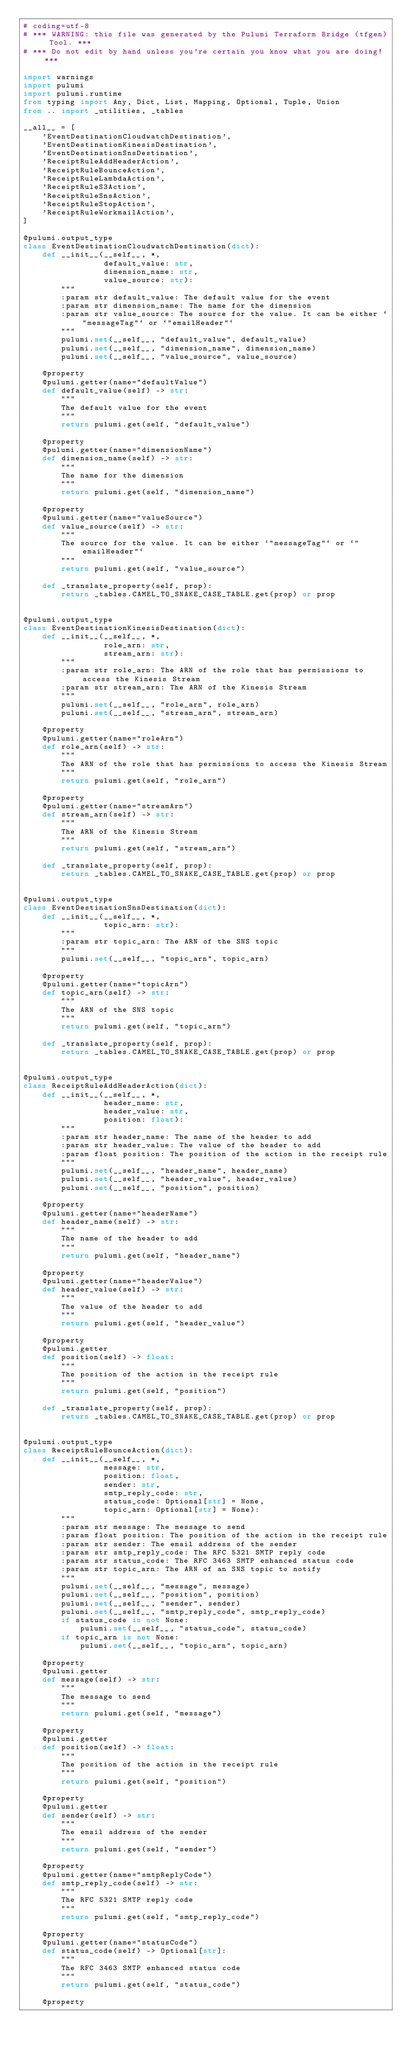<code> <loc_0><loc_0><loc_500><loc_500><_Python_># coding=utf-8
# *** WARNING: this file was generated by the Pulumi Terraform Bridge (tfgen) Tool. ***
# *** Do not edit by hand unless you're certain you know what you are doing! ***

import warnings
import pulumi
import pulumi.runtime
from typing import Any, Dict, List, Mapping, Optional, Tuple, Union
from .. import _utilities, _tables

__all__ = [
    'EventDestinationCloudwatchDestination',
    'EventDestinationKinesisDestination',
    'EventDestinationSnsDestination',
    'ReceiptRuleAddHeaderAction',
    'ReceiptRuleBounceAction',
    'ReceiptRuleLambdaAction',
    'ReceiptRuleS3Action',
    'ReceiptRuleSnsAction',
    'ReceiptRuleStopAction',
    'ReceiptRuleWorkmailAction',
]

@pulumi.output_type
class EventDestinationCloudwatchDestination(dict):
    def __init__(__self__, *,
                 default_value: str,
                 dimension_name: str,
                 value_source: str):
        """
        :param str default_value: The default value for the event
        :param str dimension_name: The name for the dimension
        :param str value_source: The source for the value. It can be either `"messageTag"` or `"emailHeader"`
        """
        pulumi.set(__self__, "default_value", default_value)
        pulumi.set(__self__, "dimension_name", dimension_name)
        pulumi.set(__self__, "value_source", value_source)

    @property
    @pulumi.getter(name="defaultValue")
    def default_value(self) -> str:
        """
        The default value for the event
        """
        return pulumi.get(self, "default_value")

    @property
    @pulumi.getter(name="dimensionName")
    def dimension_name(self) -> str:
        """
        The name for the dimension
        """
        return pulumi.get(self, "dimension_name")

    @property
    @pulumi.getter(name="valueSource")
    def value_source(self) -> str:
        """
        The source for the value. It can be either `"messageTag"` or `"emailHeader"`
        """
        return pulumi.get(self, "value_source")

    def _translate_property(self, prop):
        return _tables.CAMEL_TO_SNAKE_CASE_TABLE.get(prop) or prop


@pulumi.output_type
class EventDestinationKinesisDestination(dict):
    def __init__(__self__, *,
                 role_arn: str,
                 stream_arn: str):
        """
        :param str role_arn: The ARN of the role that has permissions to access the Kinesis Stream
        :param str stream_arn: The ARN of the Kinesis Stream
        """
        pulumi.set(__self__, "role_arn", role_arn)
        pulumi.set(__self__, "stream_arn", stream_arn)

    @property
    @pulumi.getter(name="roleArn")
    def role_arn(self) -> str:
        """
        The ARN of the role that has permissions to access the Kinesis Stream
        """
        return pulumi.get(self, "role_arn")

    @property
    @pulumi.getter(name="streamArn")
    def stream_arn(self) -> str:
        """
        The ARN of the Kinesis Stream
        """
        return pulumi.get(self, "stream_arn")

    def _translate_property(self, prop):
        return _tables.CAMEL_TO_SNAKE_CASE_TABLE.get(prop) or prop


@pulumi.output_type
class EventDestinationSnsDestination(dict):
    def __init__(__self__, *,
                 topic_arn: str):
        """
        :param str topic_arn: The ARN of the SNS topic
        """
        pulumi.set(__self__, "topic_arn", topic_arn)

    @property
    @pulumi.getter(name="topicArn")
    def topic_arn(self) -> str:
        """
        The ARN of the SNS topic
        """
        return pulumi.get(self, "topic_arn")

    def _translate_property(self, prop):
        return _tables.CAMEL_TO_SNAKE_CASE_TABLE.get(prop) or prop


@pulumi.output_type
class ReceiptRuleAddHeaderAction(dict):
    def __init__(__self__, *,
                 header_name: str,
                 header_value: str,
                 position: float):
        """
        :param str header_name: The name of the header to add
        :param str header_value: The value of the header to add
        :param float position: The position of the action in the receipt rule
        """
        pulumi.set(__self__, "header_name", header_name)
        pulumi.set(__self__, "header_value", header_value)
        pulumi.set(__self__, "position", position)

    @property
    @pulumi.getter(name="headerName")
    def header_name(self) -> str:
        """
        The name of the header to add
        """
        return pulumi.get(self, "header_name")

    @property
    @pulumi.getter(name="headerValue")
    def header_value(self) -> str:
        """
        The value of the header to add
        """
        return pulumi.get(self, "header_value")

    @property
    @pulumi.getter
    def position(self) -> float:
        """
        The position of the action in the receipt rule
        """
        return pulumi.get(self, "position")

    def _translate_property(self, prop):
        return _tables.CAMEL_TO_SNAKE_CASE_TABLE.get(prop) or prop


@pulumi.output_type
class ReceiptRuleBounceAction(dict):
    def __init__(__self__, *,
                 message: str,
                 position: float,
                 sender: str,
                 smtp_reply_code: str,
                 status_code: Optional[str] = None,
                 topic_arn: Optional[str] = None):
        """
        :param str message: The message to send
        :param float position: The position of the action in the receipt rule
        :param str sender: The email address of the sender
        :param str smtp_reply_code: The RFC 5321 SMTP reply code
        :param str status_code: The RFC 3463 SMTP enhanced status code
        :param str topic_arn: The ARN of an SNS topic to notify
        """
        pulumi.set(__self__, "message", message)
        pulumi.set(__self__, "position", position)
        pulumi.set(__self__, "sender", sender)
        pulumi.set(__self__, "smtp_reply_code", smtp_reply_code)
        if status_code is not None:
            pulumi.set(__self__, "status_code", status_code)
        if topic_arn is not None:
            pulumi.set(__self__, "topic_arn", topic_arn)

    @property
    @pulumi.getter
    def message(self) -> str:
        """
        The message to send
        """
        return pulumi.get(self, "message")

    @property
    @pulumi.getter
    def position(self) -> float:
        """
        The position of the action in the receipt rule
        """
        return pulumi.get(self, "position")

    @property
    @pulumi.getter
    def sender(self) -> str:
        """
        The email address of the sender
        """
        return pulumi.get(self, "sender")

    @property
    @pulumi.getter(name="smtpReplyCode")
    def smtp_reply_code(self) -> str:
        """
        The RFC 5321 SMTP reply code
        """
        return pulumi.get(self, "smtp_reply_code")

    @property
    @pulumi.getter(name="statusCode")
    def status_code(self) -> Optional[str]:
        """
        The RFC 3463 SMTP enhanced status code
        """
        return pulumi.get(self, "status_code")

    @property</code> 